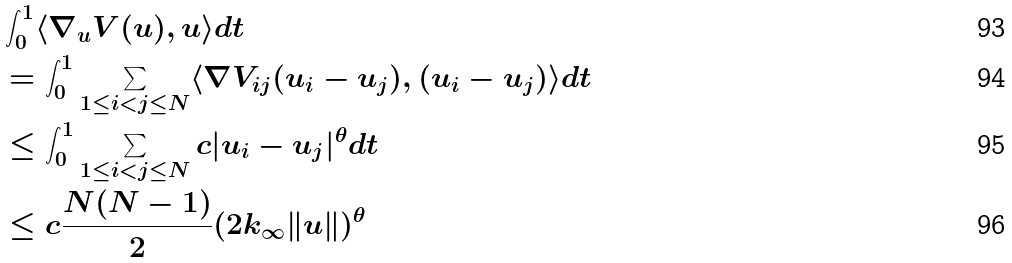<formula> <loc_0><loc_0><loc_500><loc_500>& \int _ { 0 } ^ { 1 } \langle \nabla _ { u } V ( u ) , u \rangle d t \\ & = \int _ { 0 } ^ { 1 } \underset { 1 \leq i < j \leq N } { \sum } \langle \nabla V _ { i j } ( u _ { i } - u _ { j } ) , ( u _ { i } - u _ { j } ) \rangle d t \\ & \leq \int _ { 0 } ^ { 1 } \sum _ { 1 \leq i < j \leq N } c | u _ { i } - u _ { j } | ^ { \theta } d t \\ & \leq c \frac { N ( N - 1 ) } { 2 } ( 2 k _ { \infty } \| u \| ) ^ { \theta }</formula> 